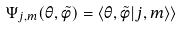<formula> <loc_0><loc_0><loc_500><loc_500>\Psi _ { j , m } ( \theta , \tilde { \phi } ) = \langle \theta , \tilde { \phi } | j , m \rangle \rangle</formula> 